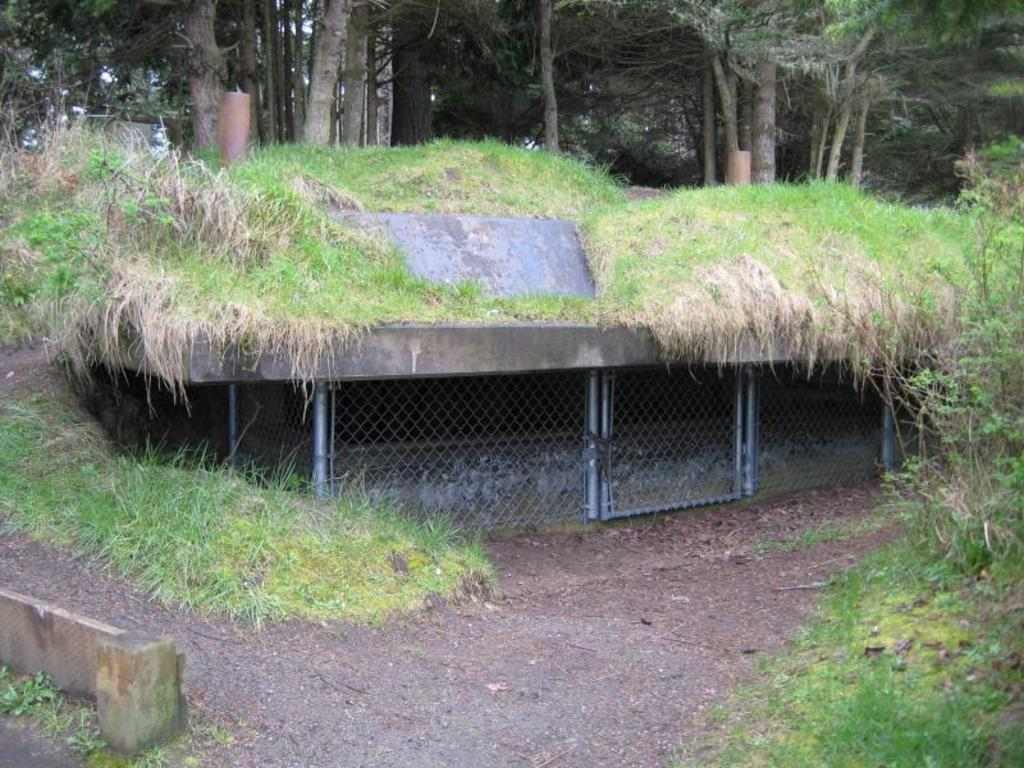What type of vegetation is present on the land in the image? There is grass on the land in the image. What can be seen on the right side of the image? There are plants on the right side of the image. What is visible in the background of the image? There are trees in the background of the image. What type of stage can be seen in the image? There is no stage present in the image. 